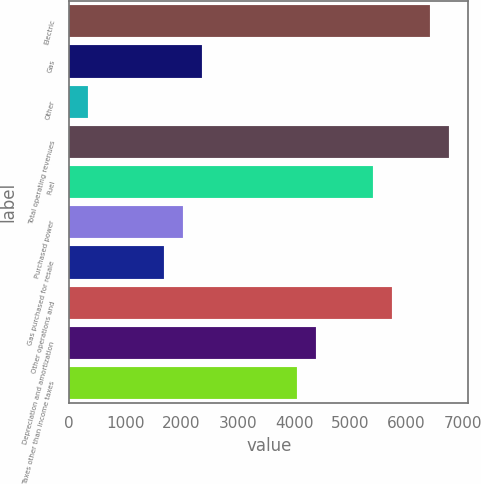Convert chart. <chart><loc_0><loc_0><loc_500><loc_500><bar_chart><fcel>Electric<fcel>Gas<fcel>Other<fcel>Total operating revenues<fcel>Fuel<fcel>Purchased power<fcel>Gas purchased for resale<fcel>Other operations and<fcel>Depreciation and amortization<fcel>Taxes other than income taxes<nl><fcel>6425<fcel>2369<fcel>341<fcel>6763<fcel>5411<fcel>2031<fcel>1693<fcel>5749<fcel>4397<fcel>4059<nl></chart> 